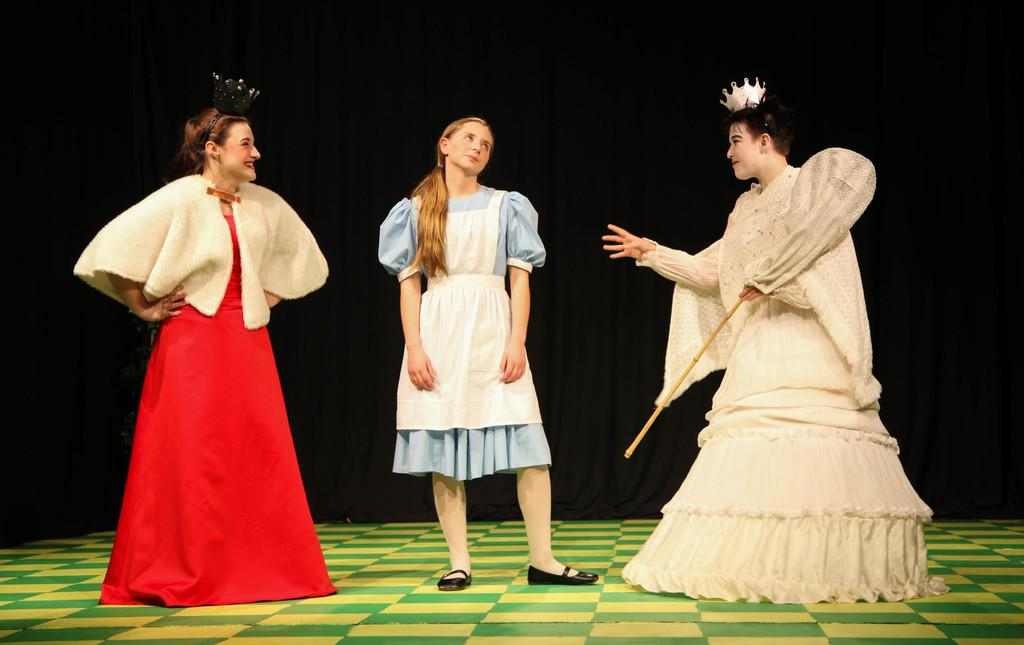What is the color of the floor in the image? The floor in the image is green and yellow colored. How many people are standing on the floor? There are three persons standing on the floor. What is the color of the background in the image? The background of the image is black colored. Can you tell me how many pens are visible in the image? There are no pens present in the image. Is there a boy in the image who is biting something? There is no boy or any indication of biting in the image. 